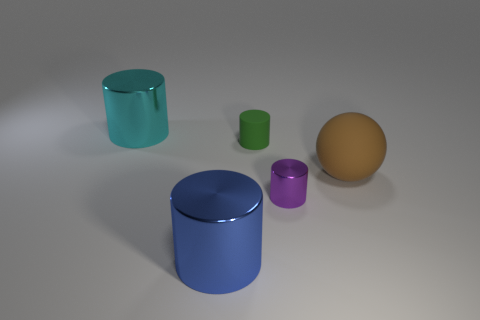Subtract all cyan cylinders. How many cylinders are left? 3 Add 1 rubber balls. How many objects exist? 6 Subtract all balls. How many objects are left? 4 Subtract all cyan cylinders. How many cylinders are left? 3 Add 1 small gray balls. How many small gray balls exist? 1 Subtract 0 purple blocks. How many objects are left? 5 Subtract 3 cylinders. How many cylinders are left? 1 Subtract all yellow balls. Subtract all yellow cylinders. How many balls are left? 1 Subtract all purple blocks. How many cyan cylinders are left? 1 Subtract all purple objects. Subtract all big cyan metallic cylinders. How many objects are left? 3 